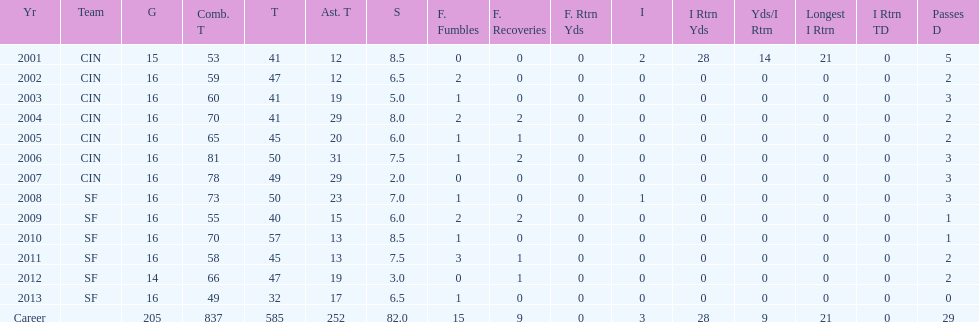What is the average number of tackles this player has had over his career? 45. Can you parse all the data within this table? {'header': ['Yr', 'Team', 'G', 'Comb. T', 'T', 'Ast. T', 'S', 'F. Fumbles', 'F. Recoveries', 'F. Rtrn Yds', 'I', 'I Rtrn Yds', 'Yds/I Rtrn', 'Longest I Rtrn', 'I Rtrn TD', 'Passes D'], 'rows': [['2001', 'CIN', '15', '53', '41', '12', '8.5', '0', '0', '0', '2', '28', '14', '21', '0', '5'], ['2002', 'CIN', '16', '59', '47', '12', '6.5', '2', '0', '0', '0', '0', '0', '0', '0', '2'], ['2003', 'CIN', '16', '60', '41', '19', '5.0', '1', '0', '0', '0', '0', '0', '0', '0', '3'], ['2004', 'CIN', '16', '70', '41', '29', '8.0', '2', '2', '0', '0', '0', '0', '0', '0', '2'], ['2005', 'CIN', '16', '65', '45', '20', '6.0', '1', '1', '0', '0', '0', '0', '0', '0', '2'], ['2006', 'CIN', '16', '81', '50', '31', '7.5', '1', '2', '0', '0', '0', '0', '0', '0', '3'], ['2007', 'CIN', '16', '78', '49', '29', '2.0', '0', '0', '0', '0', '0', '0', '0', '0', '3'], ['2008', 'SF', '16', '73', '50', '23', '7.0', '1', '0', '0', '1', '0', '0', '0', '0', '3'], ['2009', 'SF', '16', '55', '40', '15', '6.0', '2', '2', '0', '0', '0', '0', '0', '0', '1'], ['2010', 'SF', '16', '70', '57', '13', '8.5', '1', '0', '0', '0', '0', '0', '0', '0', '1'], ['2011', 'SF', '16', '58', '45', '13', '7.5', '3', '1', '0', '0', '0', '0', '0', '0', '2'], ['2012', 'SF', '14', '66', '47', '19', '3.0', '0', '1', '0', '0', '0', '0', '0', '0', '2'], ['2013', 'SF', '16', '49', '32', '17', '6.5', '1', '0', '0', '0', '0', '0', '0', '0', '0'], ['Career', '', '205', '837', '585', '252', '82.0', '15', '9', '0', '3', '28', '9', '21', '0', '29']]} 